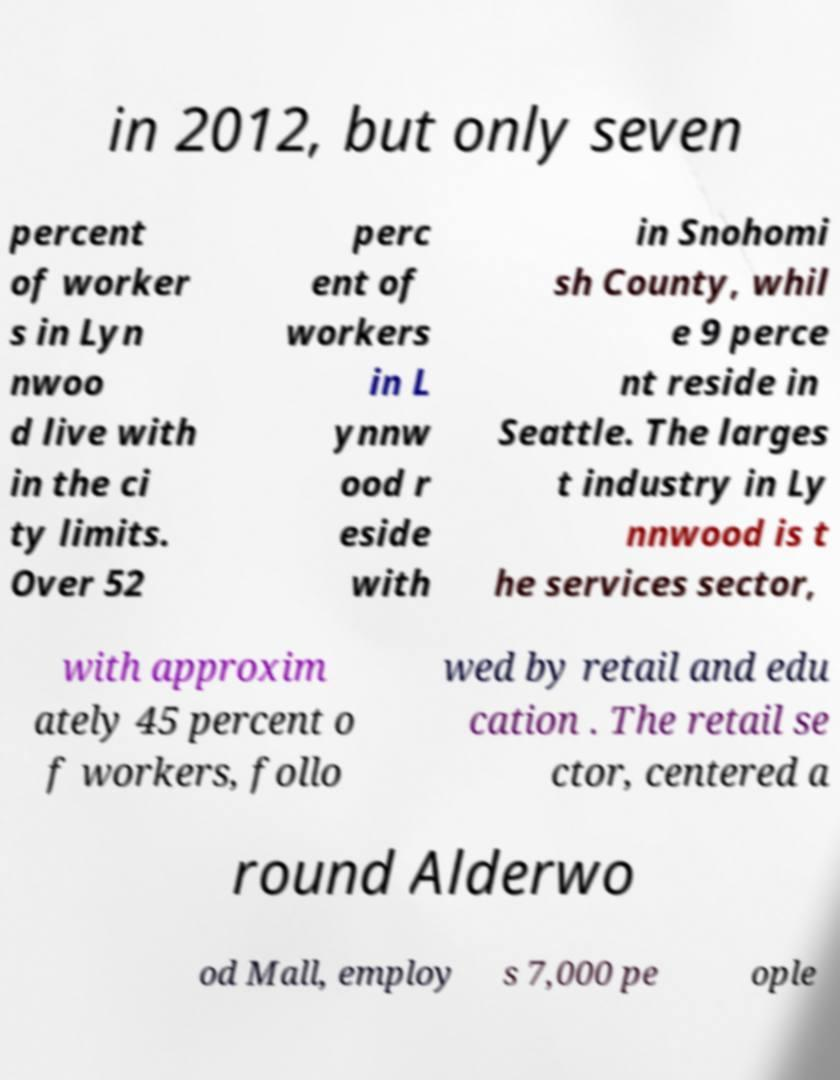Can you accurately transcribe the text from the provided image for me? in 2012, but only seven percent of worker s in Lyn nwoo d live with in the ci ty limits. Over 52 perc ent of workers in L ynnw ood r eside with in Snohomi sh County, whil e 9 perce nt reside in Seattle. The larges t industry in Ly nnwood is t he services sector, with approxim ately 45 percent o f workers, follo wed by retail and edu cation . The retail se ctor, centered a round Alderwo od Mall, employ s 7,000 pe ople 